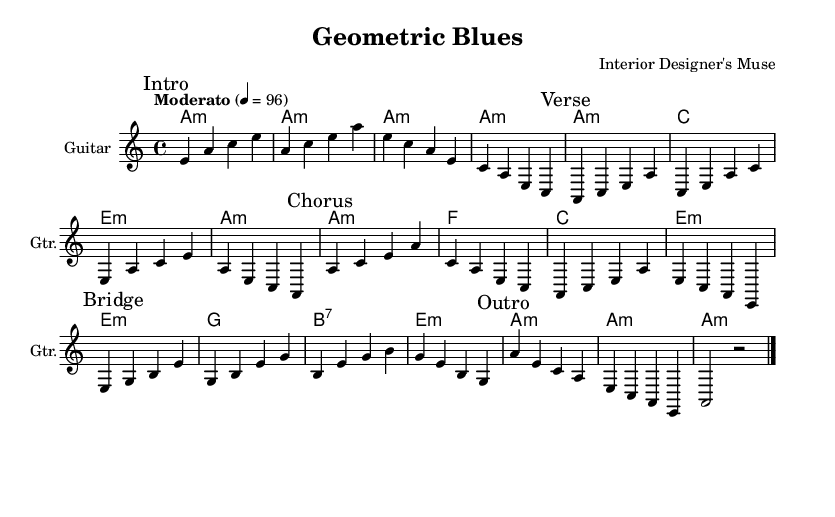What is the key signature of this music? The key signature is A minor, which has no sharps or flats.
Answer: A minor What is the time signature of this piece? The time signature is indicated by the bottom number of the fraction, which is 4 in this case, meaning there are four beats in each measure.
Answer: 4/4 What is the tempo marking given for the music? The tempo marking stated in the score indicates a moderate pace, and the speed is set at 96 beats per minute.
Answer: Moderato, 96 How many sections are there in this composition? The piece is divided into five distinct sections: Intro, Verse, Chorus, Bridge, and Outro.
Answer: Five Identify the first chord used in the Intro section. The first chord in the Intro section is shown directly beneath the staff as it aligns with the first measure, and it is an A minor chord.
Answer: A minor In which section does the bridging occur? The Bridge section is specifically marked within the music, noting a transition in tonality and rhythm following the Chorus.
Answer: Bridge Which chords are used in the Chorus section? The Chorus section showcases three specific chords: A minor, F major, and C major, in that order as indicated in the score.
Answer: A minor, F major, C major 